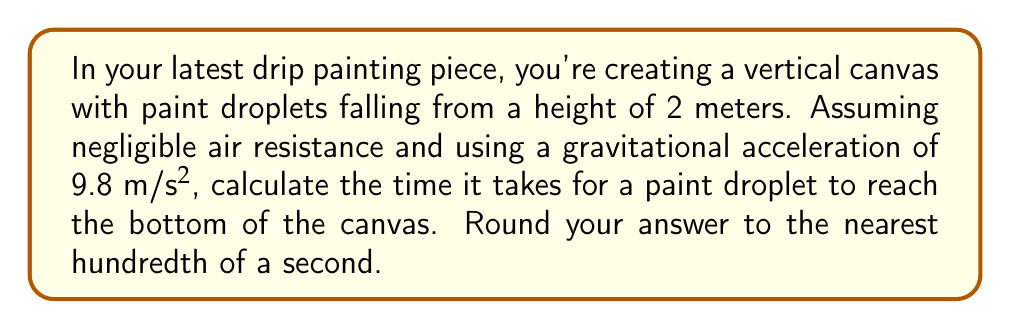Help me with this question. To solve this problem, we'll use the equation for the distance traveled by an object under constant acceleration:

$$s = \frac{1}{2}at^2$$

Where:
$s$ = distance traveled (2 meters)
$a$ = acceleration due to gravity (9.8 m/s²)
$t$ = time (what we're solving for)

Step 1: Substitute the known values into the equation:
$$2 = \frac{1}{2} \cdot 9.8 \cdot t^2$$

Step 2: Multiply both sides by 2:
$$4 = 9.8t^2$$

Step 3: Divide both sides by 9.8:
$$\frac{4}{9.8} = t^2$$

Step 4: Take the square root of both sides:
$$t = \sqrt{\frac{4}{9.8}}$$

Step 5: Calculate the result:
$$t \approx 0.6382$$

Step 6: Round to the nearest hundredth:
$$t \approx 0.64\text{ seconds}$$
Answer: 0.64 seconds 